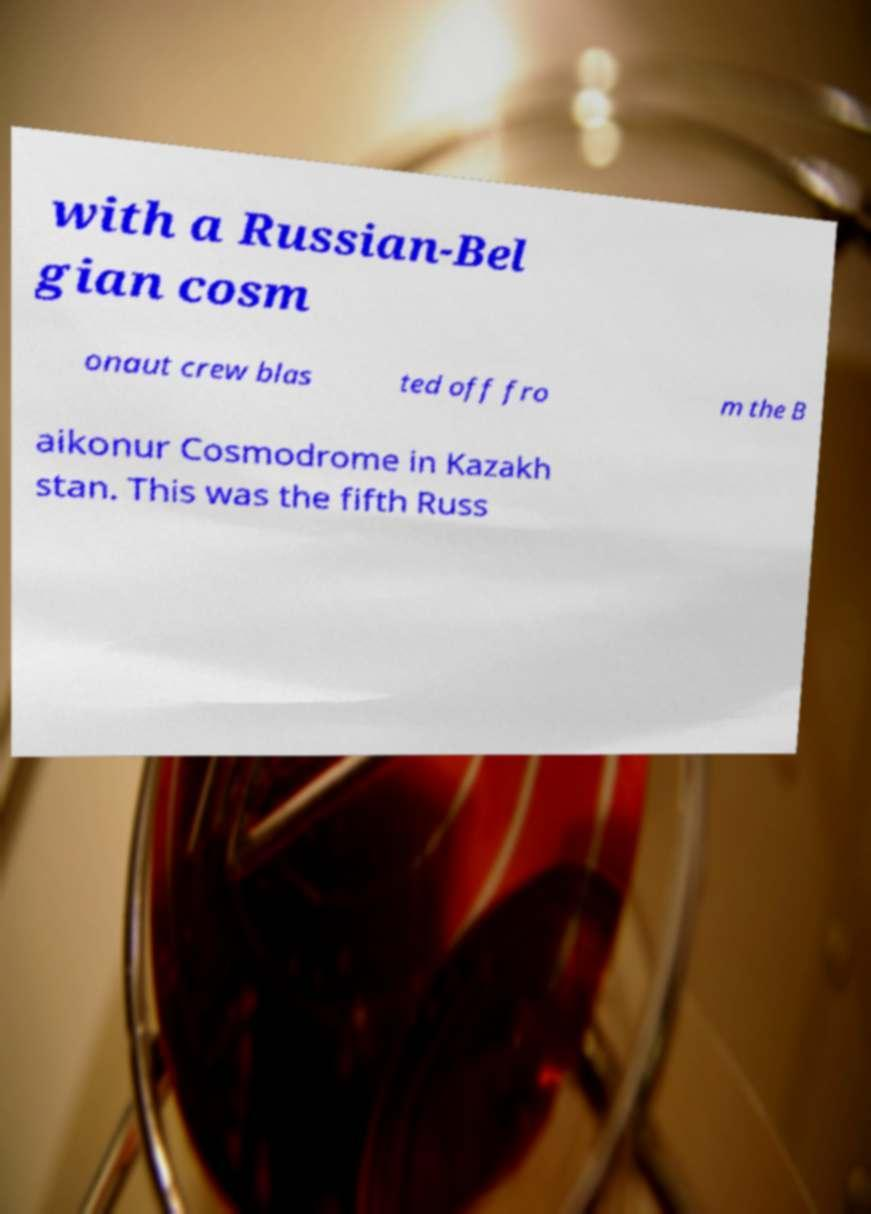I need the written content from this picture converted into text. Can you do that? with a Russian-Bel gian cosm onaut crew blas ted off fro m the B aikonur Cosmodrome in Kazakh stan. This was the fifth Russ 